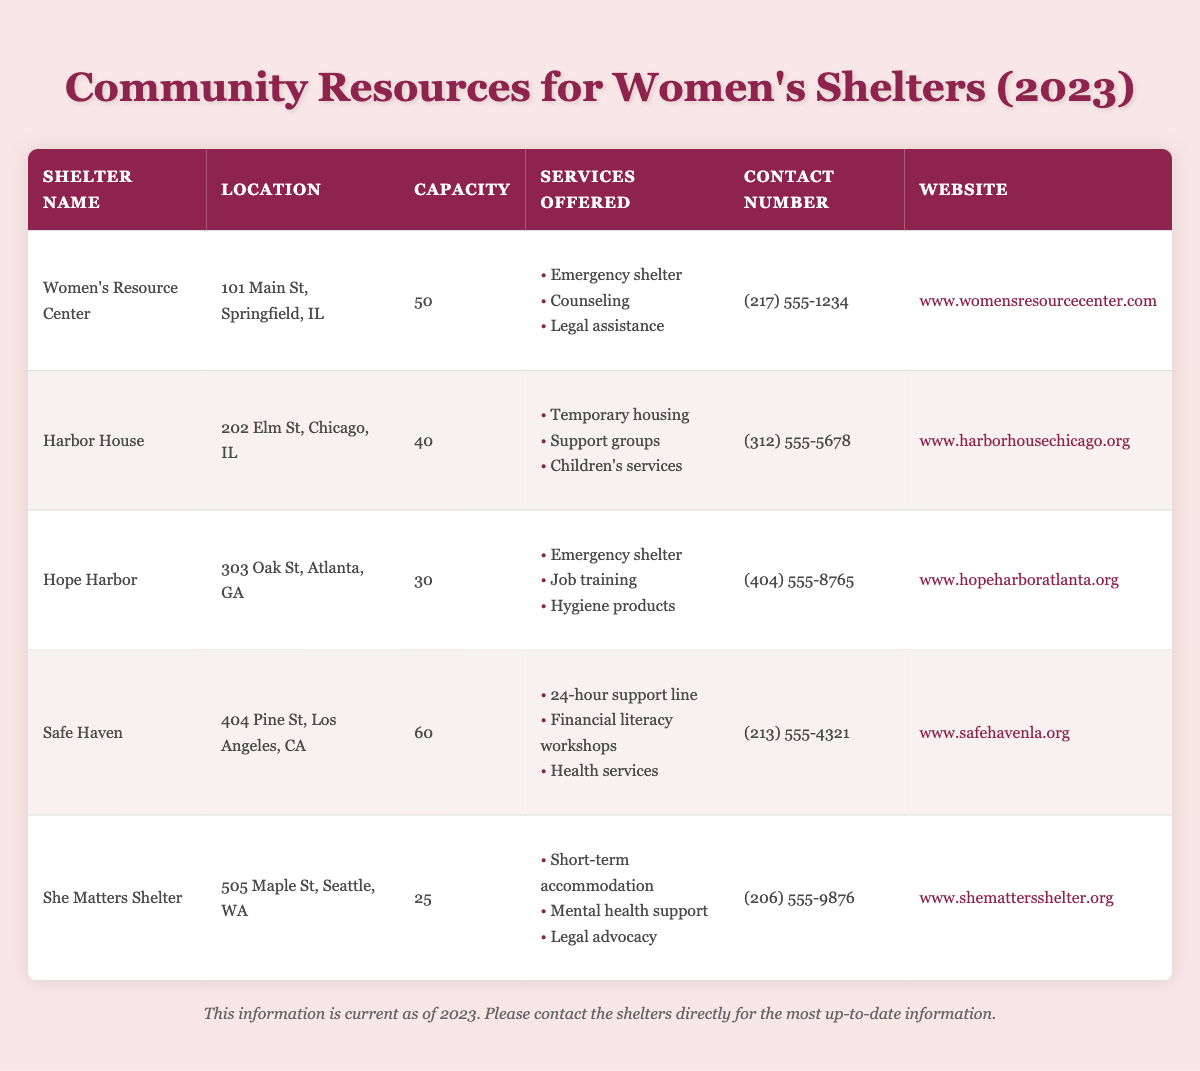What is the contact number for Hope Harbor? Looking at the table, I can see Hope Harbor is listed with its details. The contact number provided for Hope Harbor is (404) 555-8765.
Answer: (404) 555-8765 Which shelter has the largest capacity? By checking the table, I compare the capacities listed for each shelter. Safe Haven has a capacity of 60, which is more than any other shelter listed.
Answer: Safe Haven True or False: She Matters Shelter offers job training services. The table lists the services offered by She Matters Shelter, which include short-term accommodation, mental health support, and legal advocacy. Job training is not mentioned, so the statement is false.
Answer: False What is the total capacity of all the shelters combined? To find the total capacity, I add up the capacities listed for each shelter: 50 (Women's Resource Center) + 40 (Harbor House) + 30 (Hope Harbor) + 60 (Safe Haven) + 25 (She Matters Shelter) = 205.
Answer: 205 Which shelters offer legal assistance as a service? I look through the services offered by each shelter in the table. Women's Resource Center and She Matters Shelter are the only ones that list legal assistance among their services.
Answer: Women's Resource Center and She Matters Shelter What is the average capacity of the shelters? To find the average capacity, I first add the total capacities: 50 + 40 + 30 + 60 + 25 = 205. Then, I divide this total by the number of shelters, which is 5. Therefore, the average capacity is 205 / 5 = 41.
Answer: 41 True or False: Harbor House is located in Seattle, WA. The table shows that Harbor House is located at 202 Elm St, Chicago, IL, not in Seattle. Therefore, the statement is false.
Answer: False What services are offered at Safe Haven? Referring to the table, Safe Haven provides a list of services: 24-hour support line, financial literacy workshops, and health services.
Answer: 24-hour support line, financial literacy workshops, health services 